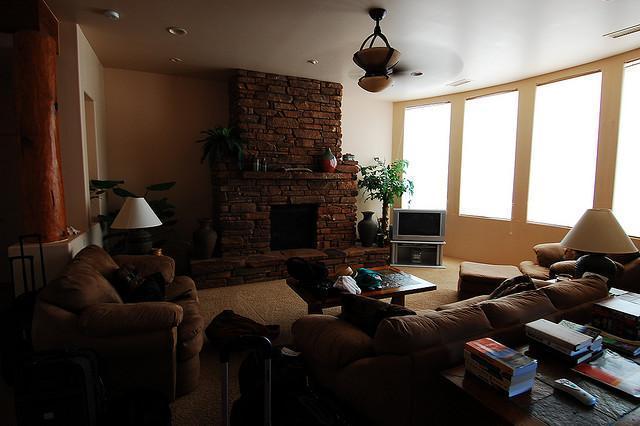How many lamps are in the room?
Give a very brief answer. 2. How many couches are there?
Give a very brief answer. 2. 